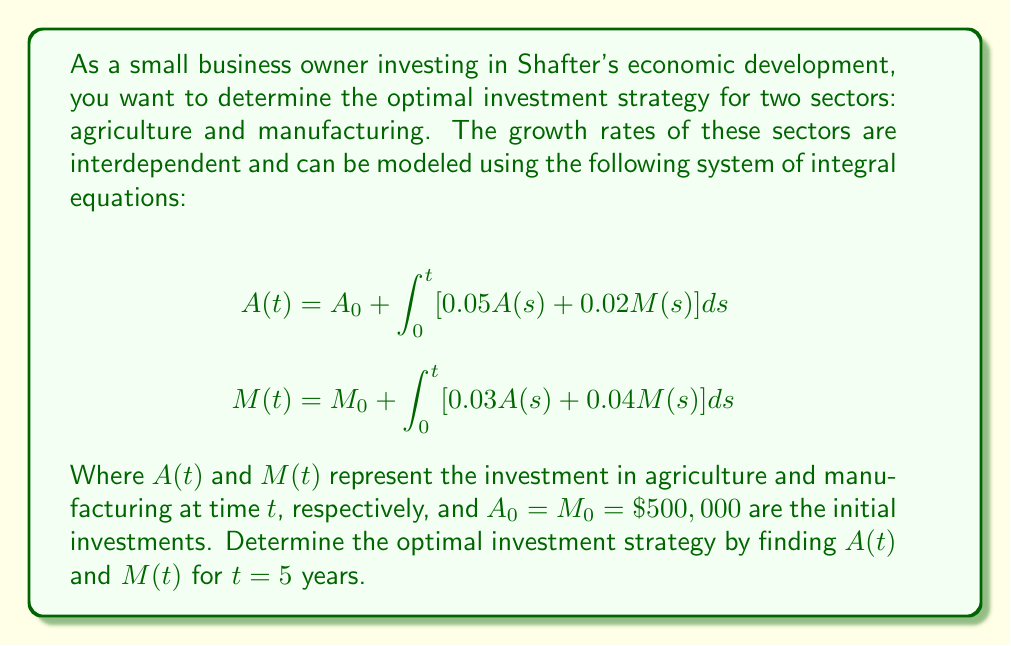Help me with this question. To solve this system of integral equations, we'll follow these steps:

1) First, differentiate both equations with respect to $t$:
   $$\frac{dA}{dt} = 0.05A(t) + 0.02M(t)$$
   $$\frac{dM}{dt} = 0.03A(t) + 0.04M(t)$$

2) Now we have a system of ordinary differential equations. Let's write it in matrix form:
   $$\begin{bmatrix} \frac{dA}{dt} \\ \frac{dM}{dt} \end{bmatrix} = \begin{bmatrix} 0.05 & 0.02 \\ 0.03 & 0.04 \end{bmatrix} \begin{bmatrix} A \\ M \end{bmatrix}$$

3) To solve this, we need to find the eigenvalues and eigenvectors of the coefficient matrix:
   $$\det(\begin{bmatrix} 0.05-\lambda & 0.02 \\ 0.03 & 0.04-\lambda \end{bmatrix}) = 0$$
   $$(0.05-\lambda)(0.04-\lambda) - 0.0006 = 0$$
   $$\lambda^2 - 0.09\lambda + 0.0014 = 0$$

4) Solving this quadratic equation:
   $$\lambda_1 \approx 0.0807, \lambda_2 \approx 0.0093$$

5) For each eigenvalue, find the corresponding eigenvector:
   For $\lambda_1$: $\vec{v_1} \approx (0.5547, 0.8321)$
   For $\lambda_2$: $\vec{v_2} \approx (-0.8321, 0.5547)$

6) The general solution is:
   $$\begin{bmatrix} A(t) \\ M(t) \end{bmatrix} = c_1e^{0.0807t}\begin{bmatrix} 0.5547 \\ 0.8321 \end{bmatrix} + c_2e^{0.0093t}\begin{bmatrix} -0.8321 \\ 0.5547 \end{bmatrix}$$

7) Use the initial conditions to find $c_1$ and $c_2$:
   $$500000 = 0.5547c_1 - 0.8321c_2$$
   $$500000 = 0.8321c_1 + 0.5547c_2$$

   Solving this system:
   $$c_1 \approx 721,605, c_2 \approx 278,395$$

8) Substitute these values and $t = 5$ into the general solution:
   $$A(5) \approx 721,605 \cdot e^{0.0807 \cdot 5} \cdot 0.5547 - 278,395 \cdot e^{0.0093 \cdot 5} \cdot 0.8321 \approx 580,335$$
   $$M(5) \approx 721,605 \cdot e^{0.0807 \cdot 5} \cdot 0.8321 + 278,395 \cdot e^{0.0093 \cdot 5} \cdot 0.5547 \approx 870,502$$
Answer: After 5 years, invest $\$580,335$ in agriculture and $\$870,502$ in manufacturing. 